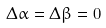Convert formula to latex. <formula><loc_0><loc_0><loc_500><loc_500>\Delta \alpha = \Delta \beta = 0</formula> 